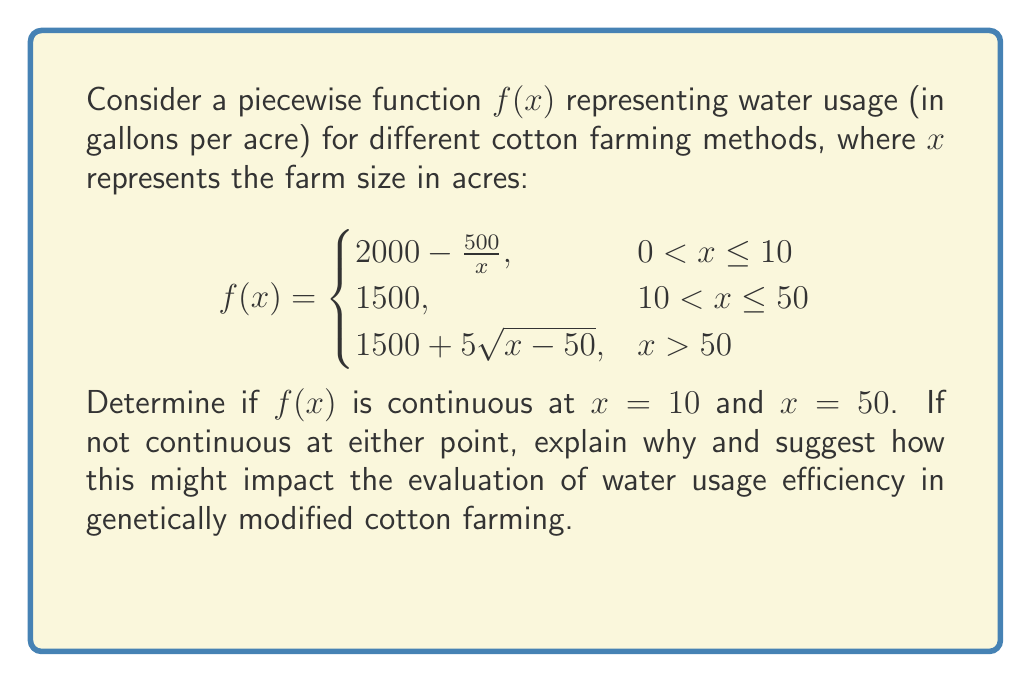Can you answer this question? To determine continuity at $x = 10$ and $x = 50$, we need to check three conditions for each point:
1. The function is defined at the point
2. The limit of the function as we approach the point from both sides exists
3. The limit equals the function value at that point

For $x = 10$:
1. $f(10)$ is defined: $f(10) = 2000 - \frac{500}{10} = 1950$
2. Left-hand limit: $\lim_{x \to 10^-} (2000 - \frac{500}{x}) = 1950$
   Right-hand limit: $\lim_{x \to 10^+} 1500 = 1500$
3. $f(10) \neq \lim_{x \to 10^+} f(x)$

Therefore, $f(x)$ is not continuous at $x = 10$ due to a jump discontinuity.

For $x = 50$:
1. $f(50)$ is defined: $f(50) = 1500$
2. Left-hand limit: $\lim_{x \to 50^-} 1500 = 1500$
   Right-hand limit: $\lim_{x \to 50^+} (1500 + 5\sqrt{x-50}) = 1500$
3. $f(50) = \lim_{x \to 50^-} f(x) = \lim_{x \to 50^+} f(x) = 1500$

Therefore, $f(x)$ is continuous at $x = 50$.

The discontinuity at $x = 10$ could represent a significant change in water usage efficiency between small farms (≤10 acres) and medium-sized farms (10-50 acres). This jump might indicate that genetically modified cotton becomes notably more water-efficient at a certain scale, which is crucial information for economic and environmental assessments. The continuity at $x = 50$ suggests a smoother transition in water usage between medium and large farms, possibly due to consistent benefits of GM cotton across larger scales.
Answer: $f(x)$ is discontinuous at $x = 10$ and continuous at $x = 50$. 